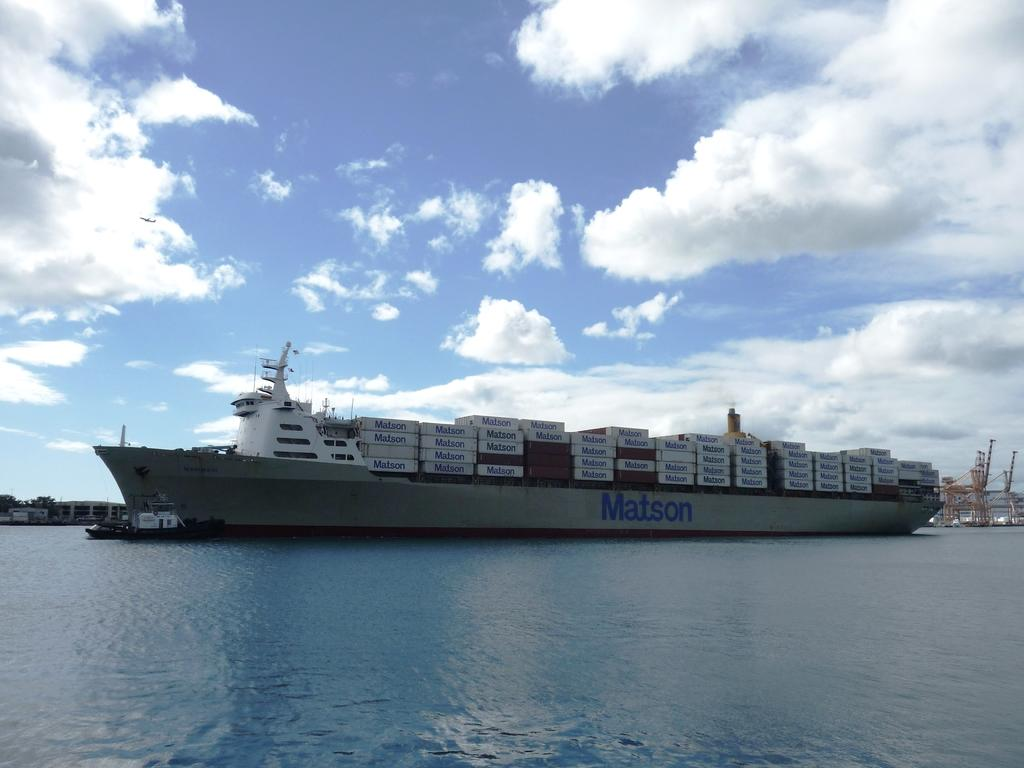What type of large vessel is present in the image? There is a container ship in the image. Are there any other watercraft visible in the image? Yes, there is a boat in the image. Where are the container ship and boat located? Both the container ship and boat are in the water. What structures can be seen in the image? There are cranes visible in the image. How would you describe the weather based on the image? The sky is cloudy in the image. How many chickens are on the container ship in the image? There are no chickens present on the container ship in the image. What type of amusement can be seen on the boat in the image? There is no amusement visible on the boat in the image. 